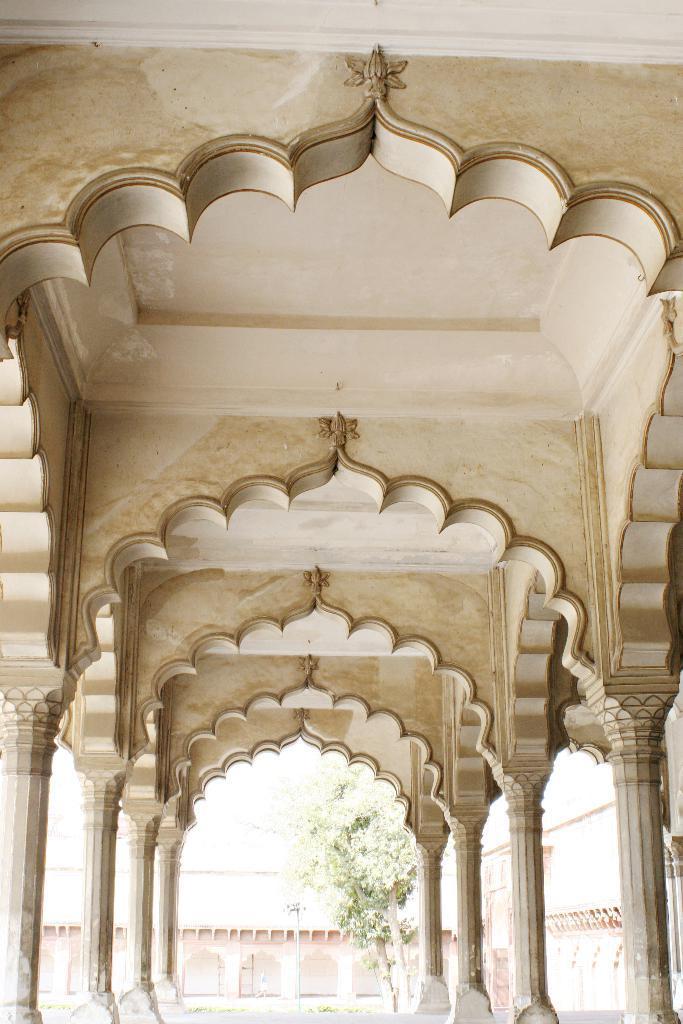Please provide a concise description of this image. In this image I can see an inside view of building. Here I can see pillars and ceiling. In the background I can see a building and a tree. 